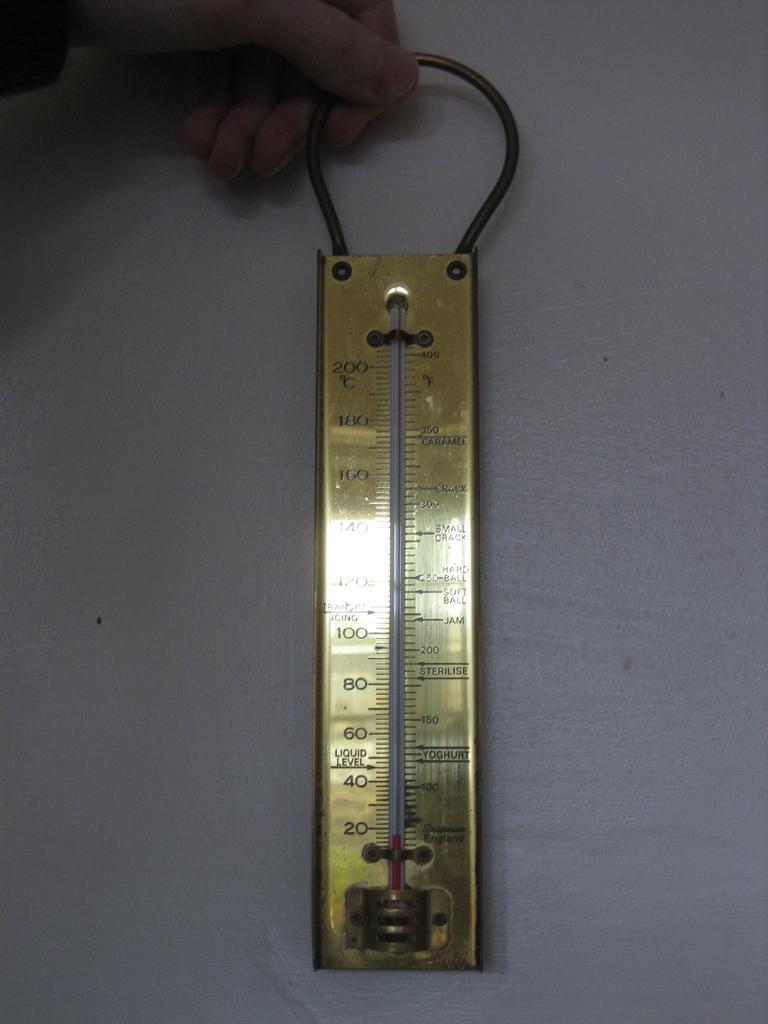Provide a one-sentence caption for the provided image. A candy thermometer that was made in England has temperature markers for Caramel and Jam. 